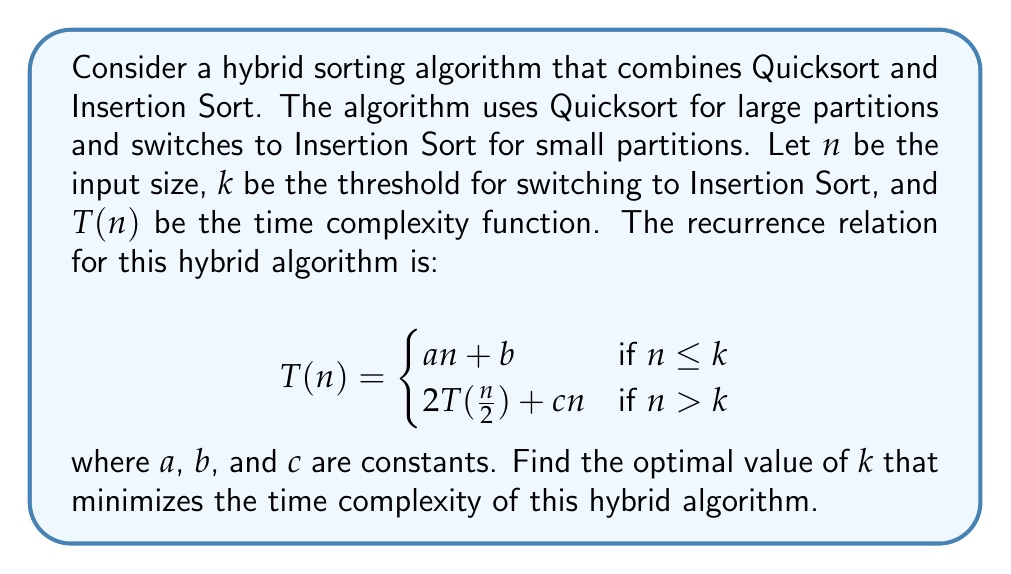Could you help me with this problem? To find the optimal value of $k$, we need to solve the system of equations where the two expressions for $T(n)$ are equal at $n = k$:

1) First, let's equate the two expressions:
   $ak + b = 2T(\frac{k}{2}) + ck$

2) We know that when $n = \frac{k}{2}$, we're in the case where $n \leq k$, so:
   $T(\frac{k}{2}) = a(\frac{k}{2}) + b$

3) Substituting this into the equation from step 1:
   $ak + b = 2(a(\frac{k}{2}) + b) + ck$

4) Simplify the right side:
   $ak + b = ak + 2b + ck$

5) Subtract $ak + b$ from both sides:
   $0 = b + ck$

6) Solve for $k$:
   $k = -\frac{b}{c}$

7) Since $k$ represents a threshold and must be positive, we take the absolute value:
   $k = |\frac{b}{c}|$

This value of $k$ represents the point where switching from Quicksort to Insertion Sort minimizes the overall time complexity of the hybrid algorithm.

To verify that this is indeed a minimum, we could take the derivative of the time complexity function with respect to $k$ and show that it's zero at this point, and positive for larger values of $k$.
Answer: $k = |\frac{b}{c}|$ 